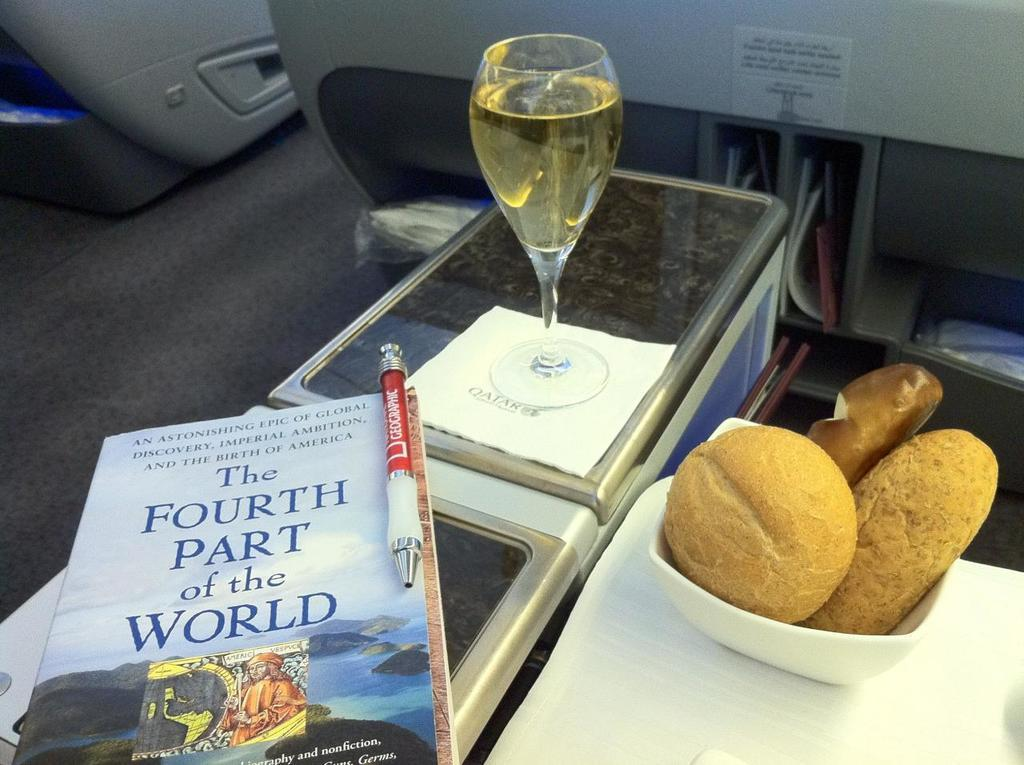<image>
Write a terse but informative summary of the picture. Book titled "The Fourth part of the World" next to some bread. 